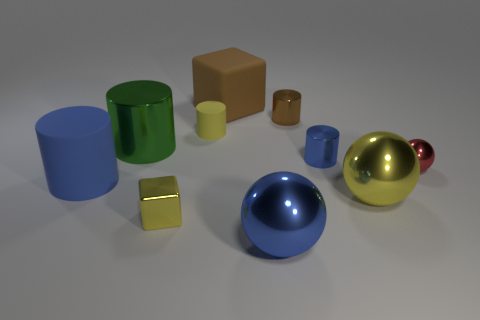There is a large thing that is on the left side of the brown block and in front of the green shiny cylinder; what is its material?
Offer a terse response. Rubber. There is a tiny cube that is made of the same material as the brown cylinder; what is its color?
Offer a very short reply. Yellow. Is the number of yellow cylinders in front of the small sphere greater than the number of tiny metallic objects behind the small brown cylinder?
Make the answer very short. No. There is a tiny rubber object; does it have the same shape as the big rubber thing in front of the green shiny thing?
Your answer should be compact. Yes. Are there fewer tiny brown metallic objects left of the small yellow shiny object than cylinders that are behind the red metal ball?
Provide a succinct answer. Yes. What is the shape of the yellow thing that is made of the same material as the large yellow sphere?
Keep it short and to the point. Cube. Is the number of green shiny things greater than the number of big red matte cylinders?
Provide a short and direct response. Yes. Do the tiny cylinder to the left of the blue ball and the big matte object that is in front of the small red metallic sphere have the same color?
Offer a very short reply. No. Are the big cylinder to the right of the blue rubber cylinder and the block that is behind the green metal cylinder made of the same material?
Offer a terse response. No. How many gray spheres have the same size as the blue shiny ball?
Give a very brief answer. 0. 